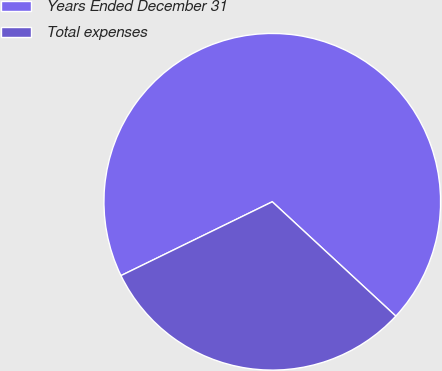Convert chart to OTSL. <chart><loc_0><loc_0><loc_500><loc_500><pie_chart><fcel>Years Ended December 31<fcel>Total expenses<nl><fcel>69.11%<fcel>30.89%<nl></chart> 